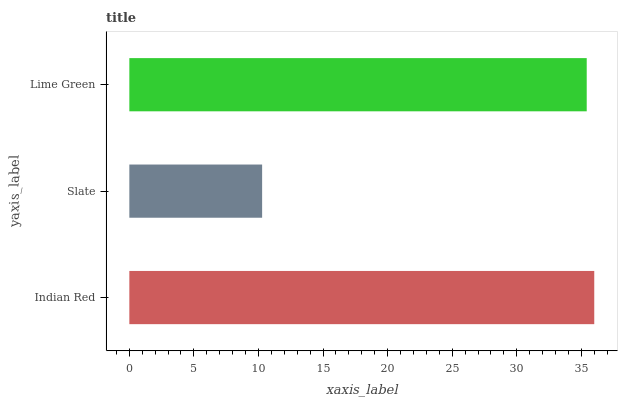Is Slate the minimum?
Answer yes or no. Yes. Is Indian Red the maximum?
Answer yes or no. Yes. Is Lime Green the minimum?
Answer yes or no. No. Is Lime Green the maximum?
Answer yes or no. No. Is Lime Green greater than Slate?
Answer yes or no. Yes. Is Slate less than Lime Green?
Answer yes or no. Yes. Is Slate greater than Lime Green?
Answer yes or no. No. Is Lime Green less than Slate?
Answer yes or no. No. Is Lime Green the high median?
Answer yes or no. Yes. Is Lime Green the low median?
Answer yes or no. Yes. Is Indian Red the high median?
Answer yes or no. No. Is Indian Red the low median?
Answer yes or no. No. 